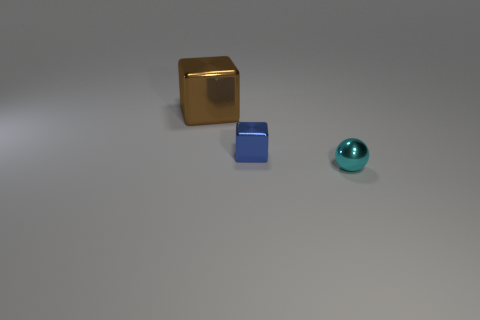Add 1 small blue blocks. How many objects exist? 4 Subtract all spheres. How many objects are left? 2 Add 3 blue blocks. How many blue blocks exist? 4 Subtract 0 gray blocks. How many objects are left? 3 Subtract all cyan metallic cylinders. Subtract all brown shiny things. How many objects are left? 2 Add 1 big cubes. How many big cubes are left? 2 